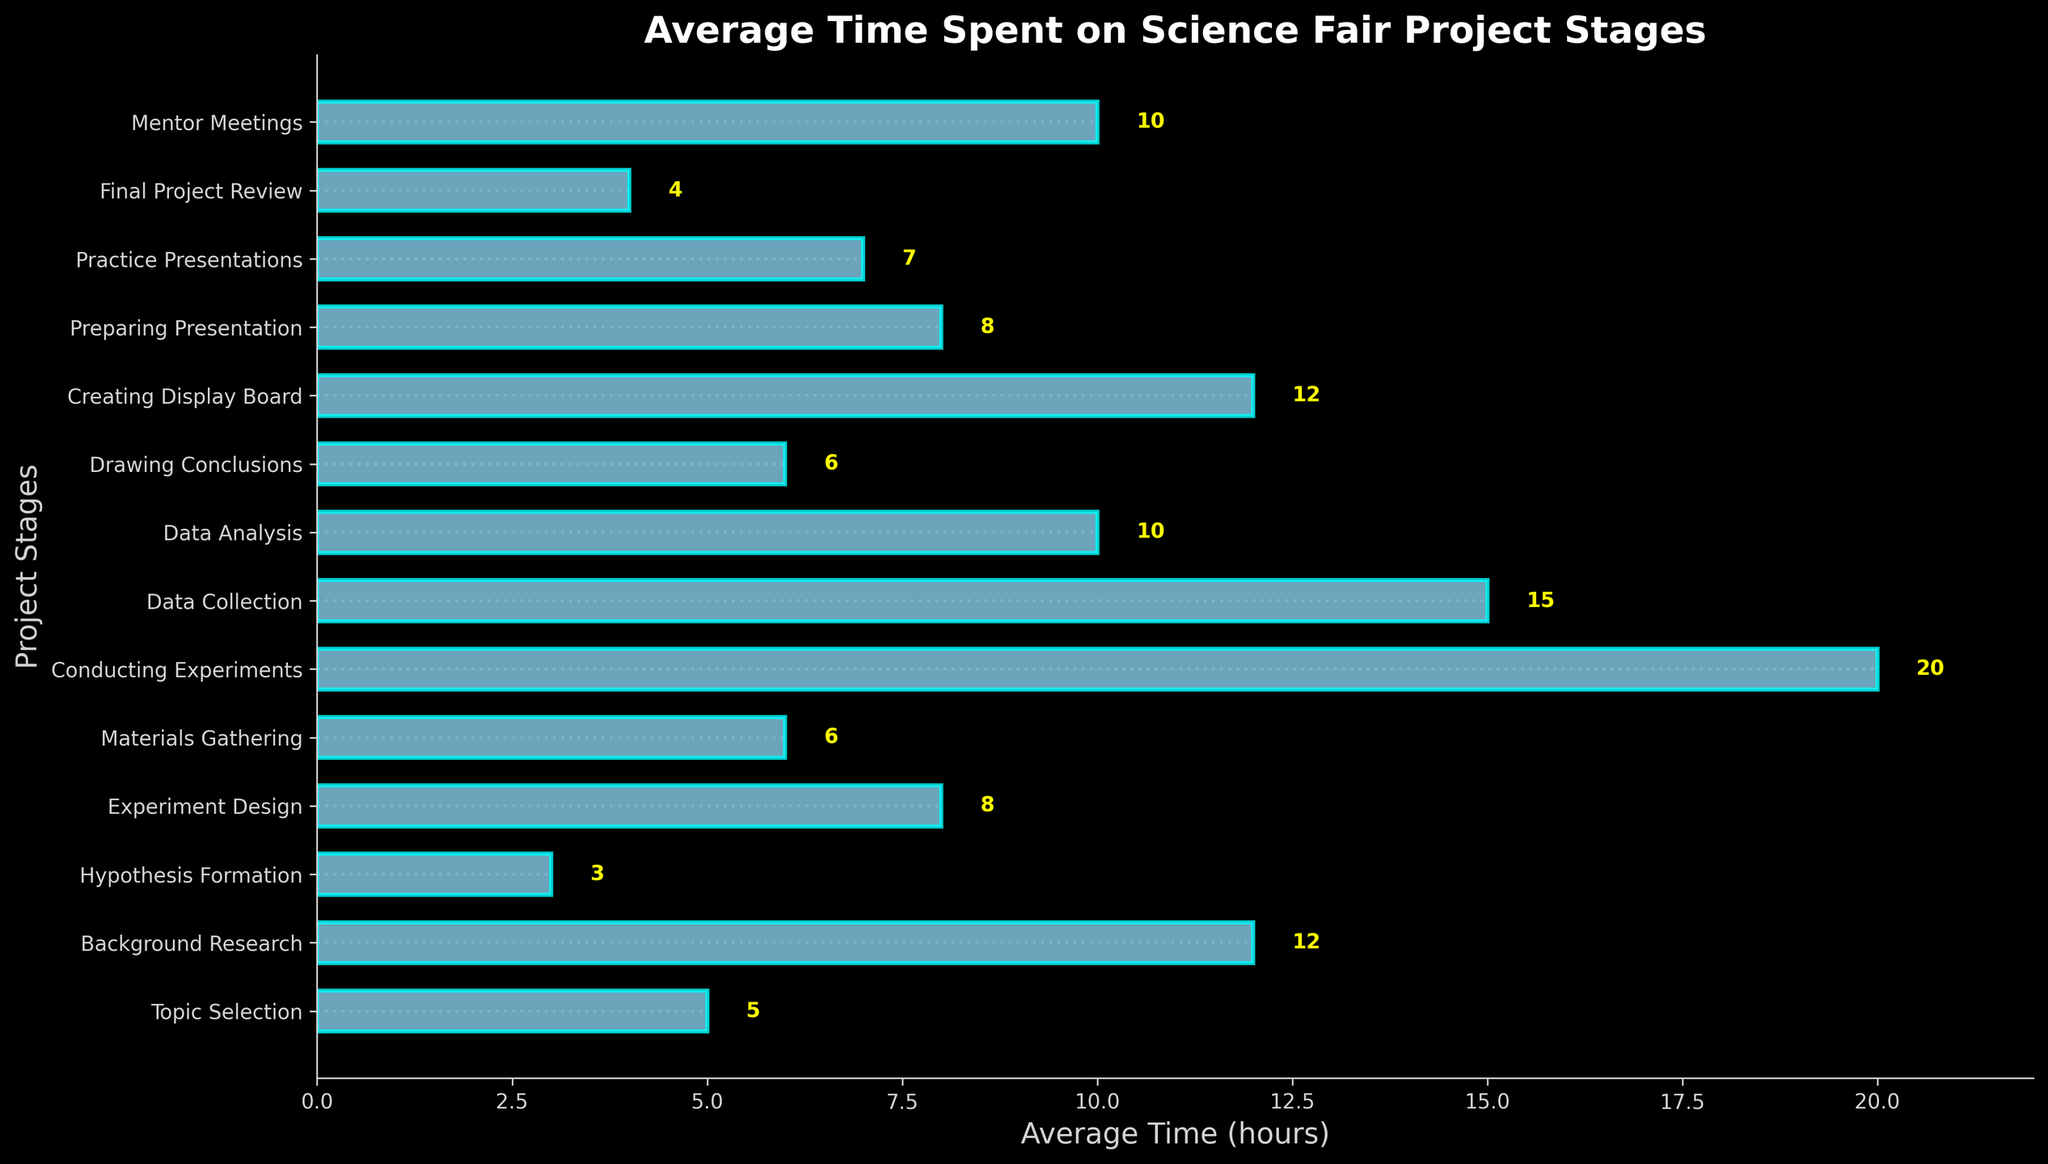what stage takes the longest average time? The bar representing "Conducting Experiments" is the longest among all the stages, indicating it takes the longest average time.
Answer: Conducting Experiments How much more time is spent on Conducting Experiments compared to Hypothesis Formation? The average time for Conducting Experiments is 20 hours, and for Hypothesis Formation, it is 3 hours. The difference is 20 - 3 = 17 hours.
Answer: 17 hours Which stage has the shortest average time? The bar for "Hypothesis Formation" is the shortest, indicating it has the shortest average time.
Answer: Hypothesis Formation What is the average time spent on Background Research and Creating Display Board combined? The time for Background Research is 12 hours, and for Creating Display Board, it's also 12 hours. The combined time is 12 + 12 = 24 hours.
Answer: 24 hours Compare the time spent on Mentor Meetings to Practice Presentations. Which one takes more time? The bar for both stages can be compared visually, with Mentor Meetings taking 10 hours and Practice Presentations taking 7 hours. Mentor Meetings take more time.
Answer: Mentor Meetings How much total time is spent on Experiment Design, Data Analysis, and Final Project Review? The time for Experiment Design is 8 hours, for Data Analysis it's 10 hours, and for Final Project Review it's 4 hours. Adding these values: 8 + 10 + 4 = 22 hours.
Answer: 22 hours How much less time is spent on Drawing Conclusions compared to Data Collection? The average time for Drawing Conclusions is 6 hours, and for Data Collection, it's 15 hours. The difference is 15 - 6 = 9 hours.
Answer: 9 hours If the time for Topic Selection were increased by 2 hours, what would be the new average time? The current average time for Topic Selection is 5 hours. Increasing by 2 hours gives 5 + 2 = 7 hours.
Answer: 7 hours Which three stages have an average time of 10 hours or more? Reviewing the bars with an average time of 10 or more hours, we see Background Research, Conducting Experiments, and Data Collection meet this criterion (12, 20, and 15 hours, respectively).
Answer: Background Research, Conducting Experiments, Data Collection 